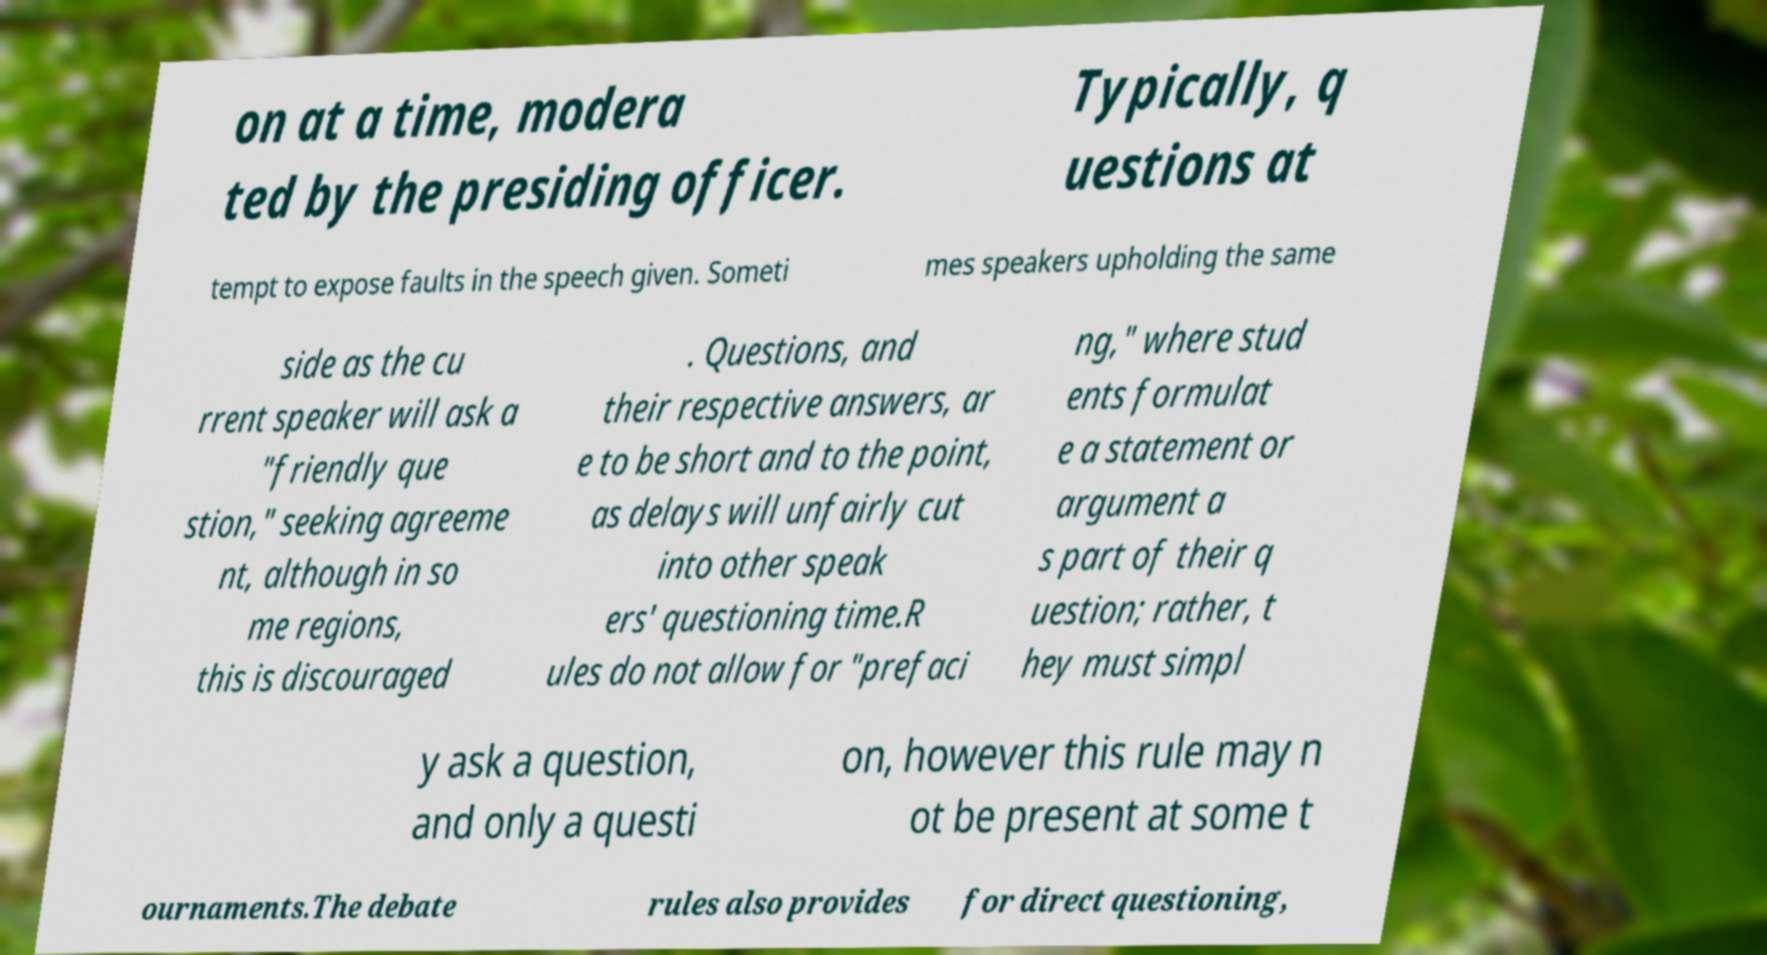Can you read and provide the text displayed in the image?This photo seems to have some interesting text. Can you extract and type it out for me? on at a time, modera ted by the presiding officer. Typically, q uestions at tempt to expose faults in the speech given. Someti mes speakers upholding the same side as the cu rrent speaker will ask a "friendly que stion," seeking agreeme nt, although in so me regions, this is discouraged . Questions, and their respective answers, ar e to be short and to the point, as delays will unfairly cut into other speak ers' questioning time.R ules do not allow for "prefaci ng," where stud ents formulat e a statement or argument a s part of their q uestion; rather, t hey must simpl y ask a question, and only a questi on, however this rule may n ot be present at some t ournaments.The debate rules also provides for direct questioning, 